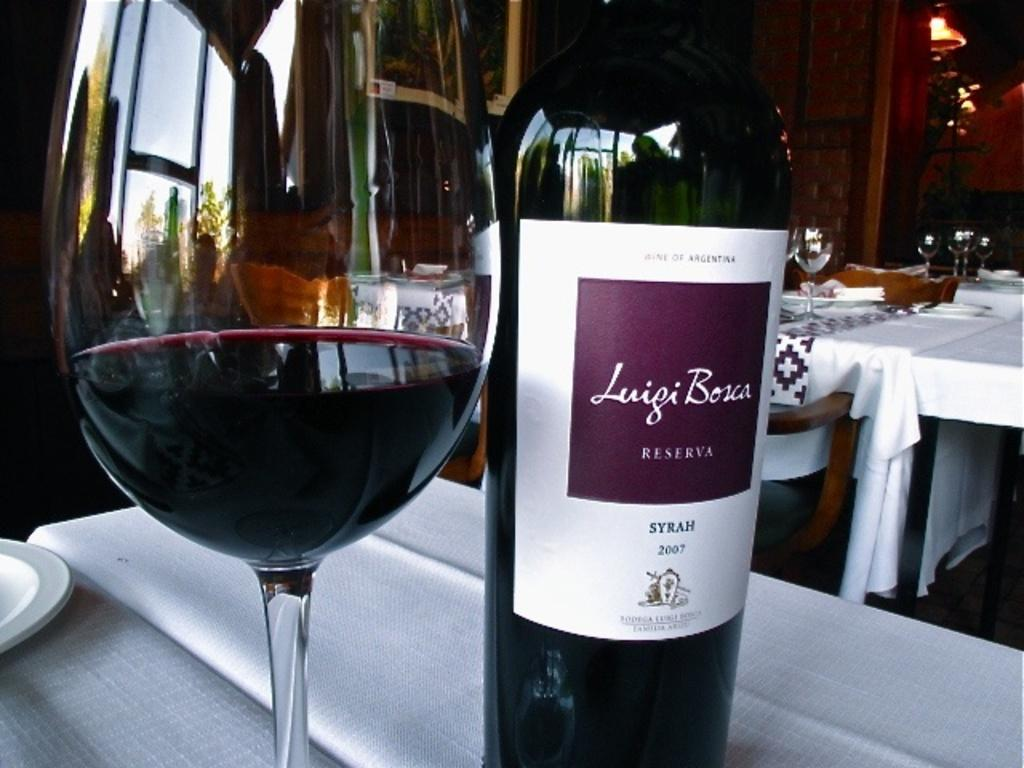<image>
Create a compact narrative representing the image presented. a glass and bottle of Luigi Bosca on a restaurant table 